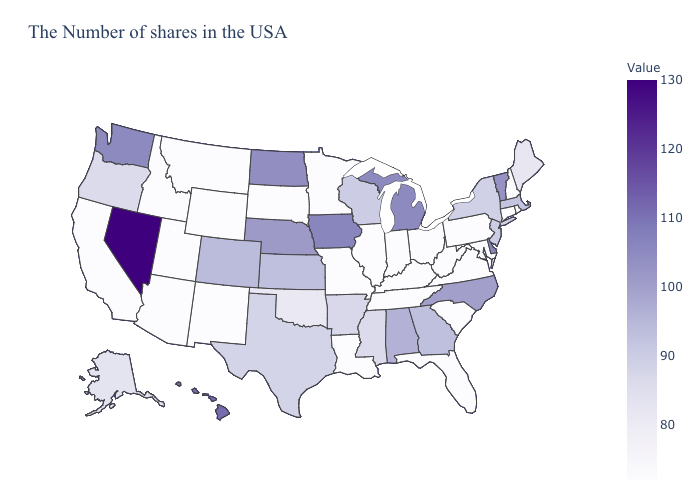Which states have the lowest value in the South?
Be succinct. Maryland, Virginia, South Carolina, West Virginia, Florida, Kentucky, Tennessee, Louisiana. Among the states that border Alabama , does Mississippi have the lowest value?
Concise answer only. No. Among the states that border Utah , which have the lowest value?
Concise answer only. Wyoming, New Mexico, Arizona, Idaho. Among the states that border Georgia , which have the lowest value?
Quick response, please. South Carolina, Florida, Tennessee. Among the states that border South Dakota , does Minnesota have the lowest value?
Give a very brief answer. Yes. Among the states that border New Mexico , does Arizona have the lowest value?
Quick response, please. Yes. 